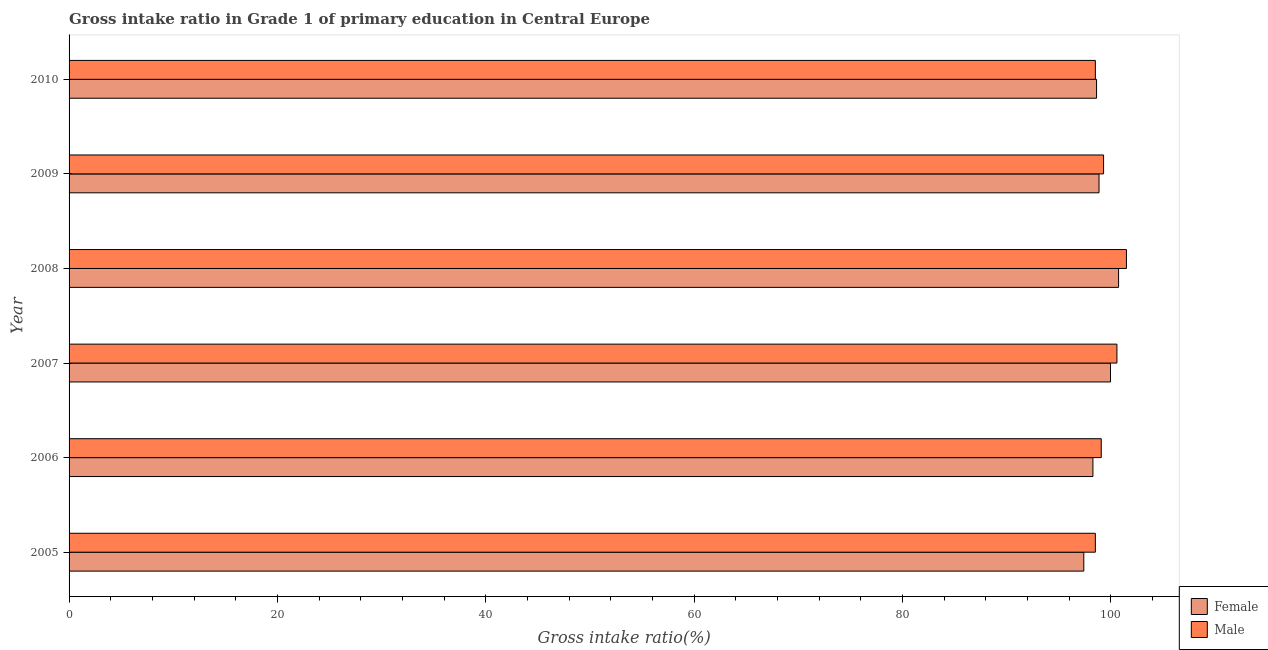How many different coloured bars are there?
Provide a succinct answer. 2. Are the number of bars per tick equal to the number of legend labels?
Make the answer very short. Yes. Are the number of bars on each tick of the Y-axis equal?
Your answer should be compact. Yes. How many bars are there on the 1st tick from the top?
Offer a very short reply. 2. How many bars are there on the 2nd tick from the bottom?
Your answer should be compact. 2. In how many cases, is the number of bars for a given year not equal to the number of legend labels?
Your response must be concise. 0. What is the gross intake ratio(female) in 2008?
Give a very brief answer. 100.74. Across all years, what is the maximum gross intake ratio(female)?
Offer a terse response. 100.74. Across all years, what is the minimum gross intake ratio(male)?
Your answer should be very brief. 98.51. In which year was the gross intake ratio(male) maximum?
Keep it short and to the point. 2008. In which year was the gross intake ratio(female) minimum?
Give a very brief answer. 2005. What is the total gross intake ratio(male) in the graph?
Your answer should be compact. 597.49. What is the difference between the gross intake ratio(female) in 2008 and that in 2009?
Offer a very short reply. 1.88. What is the difference between the gross intake ratio(female) in 2010 and the gross intake ratio(male) in 2007?
Your response must be concise. -1.95. What is the average gross intake ratio(male) per year?
Provide a short and direct response. 99.58. In the year 2010, what is the difference between the gross intake ratio(male) and gross intake ratio(female)?
Offer a terse response. -0.12. What is the ratio of the gross intake ratio(female) in 2006 to that in 2007?
Give a very brief answer. 0.98. Is the difference between the gross intake ratio(female) in 2009 and 2010 greater than the difference between the gross intake ratio(male) in 2009 and 2010?
Offer a terse response. No. What is the difference between the highest and the second highest gross intake ratio(male)?
Give a very brief answer. 0.91. What is the difference between the highest and the lowest gross intake ratio(male)?
Your answer should be very brief. 2.98. In how many years, is the gross intake ratio(female) greater than the average gross intake ratio(female) taken over all years?
Ensure brevity in your answer.  2. What does the 1st bar from the top in 2007 represents?
Give a very brief answer. Male. How many bars are there?
Your response must be concise. 12. Are the values on the major ticks of X-axis written in scientific E-notation?
Give a very brief answer. No. Does the graph contain any zero values?
Offer a terse response. No. What is the title of the graph?
Keep it short and to the point. Gross intake ratio in Grade 1 of primary education in Central Europe. Does "National Visitors" appear as one of the legend labels in the graph?
Your response must be concise. No. What is the label or title of the X-axis?
Offer a very short reply. Gross intake ratio(%). What is the Gross intake ratio(%) in Female in 2005?
Keep it short and to the point. 97.4. What is the Gross intake ratio(%) in Male in 2005?
Offer a terse response. 98.51. What is the Gross intake ratio(%) of Female in 2006?
Provide a short and direct response. 98.28. What is the Gross intake ratio(%) in Male in 2006?
Make the answer very short. 99.08. What is the Gross intake ratio(%) of Female in 2007?
Your answer should be very brief. 99.97. What is the Gross intake ratio(%) of Male in 2007?
Make the answer very short. 100.58. What is the Gross intake ratio(%) in Female in 2008?
Ensure brevity in your answer.  100.74. What is the Gross intake ratio(%) in Male in 2008?
Ensure brevity in your answer.  101.5. What is the Gross intake ratio(%) in Female in 2009?
Keep it short and to the point. 98.87. What is the Gross intake ratio(%) in Male in 2009?
Make the answer very short. 99.3. What is the Gross intake ratio(%) in Female in 2010?
Your answer should be very brief. 98.63. What is the Gross intake ratio(%) in Male in 2010?
Provide a succinct answer. 98.51. Across all years, what is the maximum Gross intake ratio(%) in Female?
Provide a succinct answer. 100.74. Across all years, what is the maximum Gross intake ratio(%) of Male?
Make the answer very short. 101.5. Across all years, what is the minimum Gross intake ratio(%) in Female?
Provide a short and direct response. 97.4. Across all years, what is the minimum Gross intake ratio(%) of Male?
Provide a succinct answer. 98.51. What is the total Gross intake ratio(%) of Female in the graph?
Your answer should be compact. 593.89. What is the total Gross intake ratio(%) in Male in the graph?
Your response must be concise. 597.49. What is the difference between the Gross intake ratio(%) in Female in 2005 and that in 2006?
Provide a succinct answer. -0.88. What is the difference between the Gross intake ratio(%) in Male in 2005 and that in 2006?
Your answer should be very brief. -0.57. What is the difference between the Gross intake ratio(%) in Female in 2005 and that in 2007?
Ensure brevity in your answer.  -2.56. What is the difference between the Gross intake ratio(%) in Male in 2005 and that in 2007?
Offer a terse response. -2.07. What is the difference between the Gross intake ratio(%) in Female in 2005 and that in 2008?
Give a very brief answer. -3.34. What is the difference between the Gross intake ratio(%) of Male in 2005 and that in 2008?
Offer a terse response. -2.98. What is the difference between the Gross intake ratio(%) of Female in 2005 and that in 2009?
Your answer should be very brief. -1.46. What is the difference between the Gross intake ratio(%) of Male in 2005 and that in 2009?
Provide a succinct answer. -0.79. What is the difference between the Gross intake ratio(%) in Female in 2005 and that in 2010?
Make the answer very short. -1.23. What is the difference between the Gross intake ratio(%) of Male in 2005 and that in 2010?
Your response must be concise. -0. What is the difference between the Gross intake ratio(%) of Female in 2006 and that in 2007?
Your answer should be very brief. -1.69. What is the difference between the Gross intake ratio(%) in Male in 2006 and that in 2007?
Your answer should be compact. -1.5. What is the difference between the Gross intake ratio(%) of Female in 2006 and that in 2008?
Ensure brevity in your answer.  -2.46. What is the difference between the Gross intake ratio(%) of Male in 2006 and that in 2008?
Your answer should be compact. -2.42. What is the difference between the Gross intake ratio(%) of Female in 2006 and that in 2009?
Ensure brevity in your answer.  -0.59. What is the difference between the Gross intake ratio(%) in Male in 2006 and that in 2009?
Give a very brief answer. -0.22. What is the difference between the Gross intake ratio(%) of Female in 2006 and that in 2010?
Give a very brief answer. -0.35. What is the difference between the Gross intake ratio(%) of Male in 2006 and that in 2010?
Provide a short and direct response. 0.57. What is the difference between the Gross intake ratio(%) of Female in 2007 and that in 2008?
Provide a succinct answer. -0.78. What is the difference between the Gross intake ratio(%) in Male in 2007 and that in 2008?
Keep it short and to the point. -0.91. What is the difference between the Gross intake ratio(%) of Female in 2007 and that in 2009?
Make the answer very short. 1.1. What is the difference between the Gross intake ratio(%) in Male in 2007 and that in 2009?
Your answer should be very brief. 1.28. What is the difference between the Gross intake ratio(%) in Female in 2007 and that in 2010?
Give a very brief answer. 1.34. What is the difference between the Gross intake ratio(%) of Male in 2007 and that in 2010?
Ensure brevity in your answer.  2.07. What is the difference between the Gross intake ratio(%) of Female in 2008 and that in 2009?
Offer a terse response. 1.88. What is the difference between the Gross intake ratio(%) of Male in 2008 and that in 2009?
Provide a succinct answer. 2.19. What is the difference between the Gross intake ratio(%) in Female in 2008 and that in 2010?
Ensure brevity in your answer.  2.11. What is the difference between the Gross intake ratio(%) of Male in 2008 and that in 2010?
Ensure brevity in your answer.  2.98. What is the difference between the Gross intake ratio(%) of Female in 2009 and that in 2010?
Make the answer very short. 0.24. What is the difference between the Gross intake ratio(%) of Male in 2009 and that in 2010?
Provide a short and direct response. 0.79. What is the difference between the Gross intake ratio(%) of Female in 2005 and the Gross intake ratio(%) of Male in 2006?
Your answer should be very brief. -1.68. What is the difference between the Gross intake ratio(%) in Female in 2005 and the Gross intake ratio(%) in Male in 2007?
Offer a terse response. -3.18. What is the difference between the Gross intake ratio(%) of Female in 2005 and the Gross intake ratio(%) of Male in 2008?
Offer a terse response. -4.09. What is the difference between the Gross intake ratio(%) in Female in 2005 and the Gross intake ratio(%) in Male in 2009?
Your answer should be compact. -1.9. What is the difference between the Gross intake ratio(%) in Female in 2005 and the Gross intake ratio(%) in Male in 2010?
Your response must be concise. -1.11. What is the difference between the Gross intake ratio(%) in Female in 2006 and the Gross intake ratio(%) in Male in 2007?
Your answer should be very brief. -2.3. What is the difference between the Gross intake ratio(%) of Female in 2006 and the Gross intake ratio(%) of Male in 2008?
Your answer should be compact. -3.22. What is the difference between the Gross intake ratio(%) in Female in 2006 and the Gross intake ratio(%) in Male in 2009?
Your answer should be very brief. -1.02. What is the difference between the Gross intake ratio(%) of Female in 2006 and the Gross intake ratio(%) of Male in 2010?
Ensure brevity in your answer.  -0.23. What is the difference between the Gross intake ratio(%) in Female in 2007 and the Gross intake ratio(%) in Male in 2008?
Your answer should be compact. -1.53. What is the difference between the Gross intake ratio(%) in Female in 2007 and the Gross intake ratio(%) in Male in 2009?
Offer a terse response. 0.66. What is the difference between the Gross intake ratio(%) of Female in 2007 and the Gross intake ratio(%) of Male in 2010?
Your answer should be very brief. 1.45. What is the difference between the Gross intake ratio(%) in Female in 2008 and the Gross intake ratio(%) in Male in 2009?
Your answer should be very brief. 1.44. What is the difference between the Gross intake ratio(%) in Female in 2008 and the Gross intake ratio(%) in Male in 2010?
Provide a succinct answer. 2.23. What is the difference between the Gross intake ratio(%) in Female in 2009 and the Gross intake ratio(%) in Male in 2010?
Provide a succinct answer. 0.35. What is the average Gross intake ratio(%) of Female per year?
Provide a succinct answer. 98.98. What is the average Gross intake ratio(%) of Male per year?
Your answer should be compact. 99.58. In the year 2005, what is the difference between the Gross intake ratio(%) of Female and Gross intake ratio(%) of Male?
Keep it short and to the point. -1.11. In the year 2006, what is the difference between the Gross intake ratio(%) of Female and Gross intake ratio(%) of Male?
Your answer should be very brief. -0.8. In the year 2007, what is the difference between the Gross intake ratio(%) of Female and Gross intake ratio(%) of Male?
Provide a short and direct response. -0.62. In the year 2008, what is the difference between the Gross intake ratio(%) of Female and Gross intake ratio(%) of Male?
Your answer should be compact. -0.75. In the year 2009, what is the difference between the Gross intake ratio(%) in Female and Gross intake ratio(%) in Male?
Offer a very short reply. -0.44. In the year 2010, what is the difference between the Gross intake ratio(%) of Female and Gross intake ratio(%) of Male?
Your answer should be compact. 0.12. What is the ratio of the Gross intake ratio(%) in Female in 2005 to that in 2007?
Provide a short and direct response. 0.97. What is the ratio of the Gross intake ratio(%) in Male in 2005 to that in 2007?
Provide a short and direct response. 0.98. What is the ratio of the Gross intake ratio(%) in Female in 2005 to that in 2008?
Give a very brief answer. 0.97. What is the ratio of the Gross intake ratio(%) in Male in 2005 to that in 2008?
Ensure brevity in your answer.  0.97. What is the ratio of the Gross intake ratio(%) in Female in 2005 to that in 2009?
Your answer should be compact. 0.99. What is the ratio of the Gross intake ratio(%) of Female in 2005 to that in 2010?
Make the answer very short. 0.99. What is the ratio of the Gross intake ratio(%) of Male in 2005 to that in 2010?
Your answer should be compact. 1. What is the ratio of the Gross intake ratio(%) of Female in 2006 to that in 2007?
Keep it short and to the point. 0.98. What is the ratio of the Gross intake ratio(%) in Male in 2006 to that in 2007?
Ensure brevity in your answer.  0.98. What is the ratio of the Gross intake ratio(%) in Female in 2006 to that in 2008?
Your answer should be compact. 0.98. What is the ratio of the Gross intake ratio(%) in Male in 2006 to that in 2008?
Keep it short and to the point. 0.98. What is the ratio of the Gross intake ratio(%) in Male in 2006 to that in 2010?
Provide a succinct answer. 1.01. What is the ratio of the Gross intake ratio(%) of Male in 2007 to that in 2008?
Offer a very short reply. 0.99. What is the ratio of the Gross intake ratio(%) in Female in 2007 to that in 2009?
Provide a succinct answer. 1.01. What is the ratio of the Gross intake ratio(%) in Male in 2007 to that in 2009?
Provide a short and direct response. 1.01. What is the ratio of the Gross intake ratio(%) of Female in 2007 to that in 2010?
Your answer should be very brief. 1.01. What is the ratio of the Gross intake ratio(%) in Female in 2008 to that in 2009?
Provide a succinct answer. 1.02. What is the ratio of the Gross intake ratio(%) in Male in 2008 to that in 2009?
Your answer should be compact. 1.02. What is the ratio of the Gross intake ratio(%) of Female in 2008 to that in 2010?
Keep it short and to the point. 1.02. What is the ratio of the Gross intake ratio(%) of Male in 2008 to that in 2010?
Give a very brief answer. 1.03. What is the ratio of the Gross intake ratio(%) in Male in 2009 to that in 2010?
Offer a very short reply. 1.01. What is the difference between the highest and the second highest Gross intake ratio(%) in Female?
Ensure brevity in your answer.  0.78. What is the difference between the highest and the second highest Gross intake ratio(%) in Male?
Your response must be concise. 0.91. What is the difference between the highest and the lowest Gross intake ratio(%) of Female?
Your response must be concise. 3.34. What is the difference between the highest and the lowest Gross intake ratio(%) in Male?
Your answer should be very brief. 2.98. 